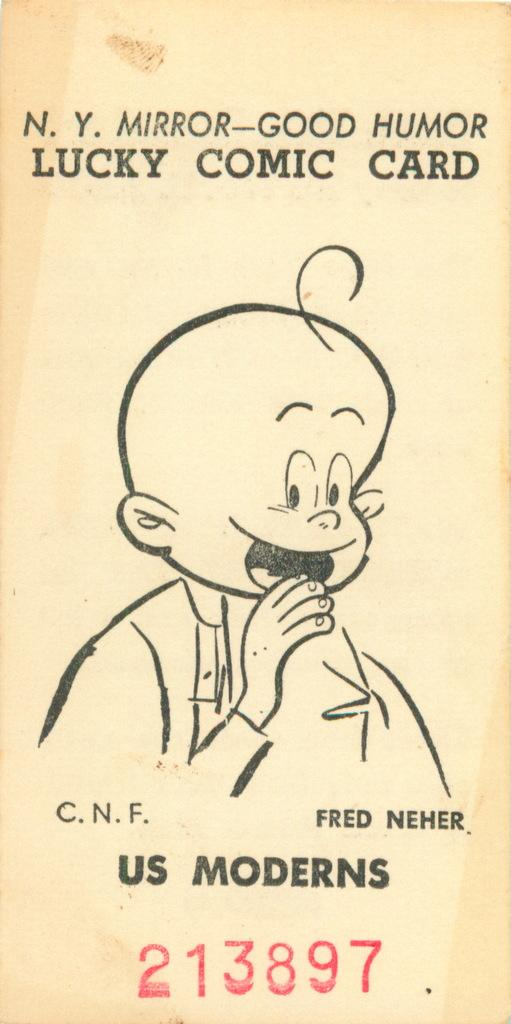What is the main subject of the paper in the image? There is a person depicted on the paper. What is unique about the person's appearance? The person has a toy head. Is there any text on the paper? Yes, there is writing on the paper. How does the person on the paper express their feelings of hate towards the letter? There is no letter present in the image, and the person's feelings are not mentioned or depicted. 